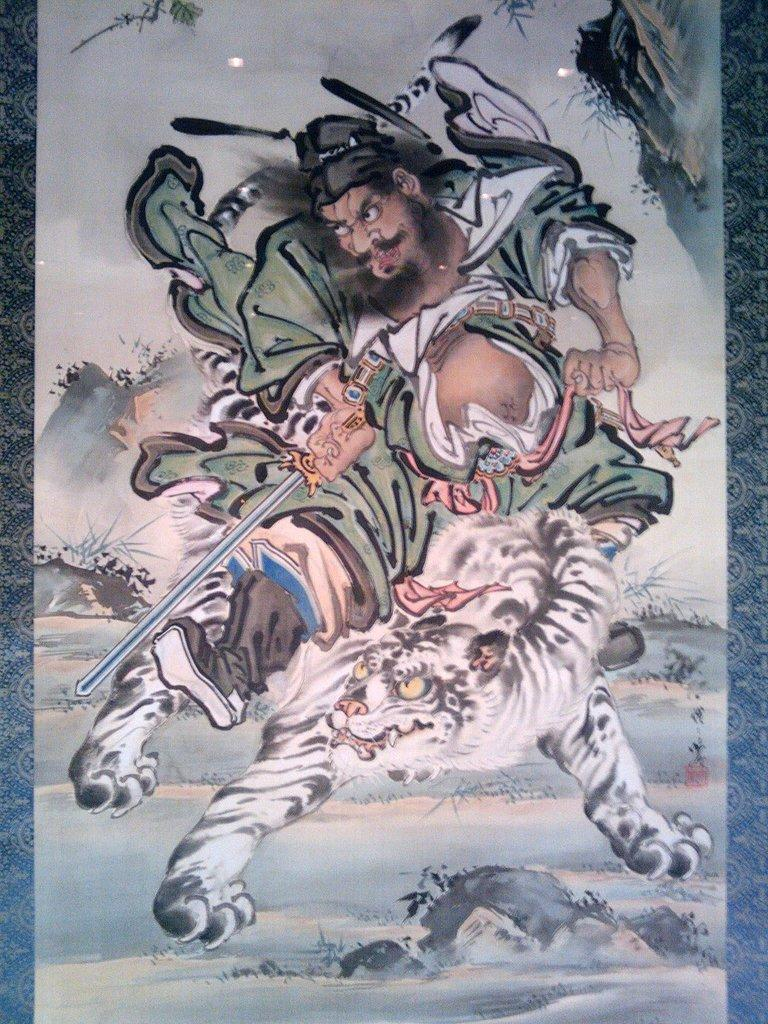What type of picture is the image? The image is an animated picture. What is the person in the image holding? The person is holding a weapon in the image. What is the person sitting on in the image? The person is sitting on an animal in the image. What celestial bodies can be seen in the image? There are planets visible in the image. What part of the natural environment is visible in the image? The sky is visible in the image. What type of zebra can be seen wearing a watch in the image? There is no zebra or watch present in the image. How many cows are visible in the image? There are no cows visible in the image. 